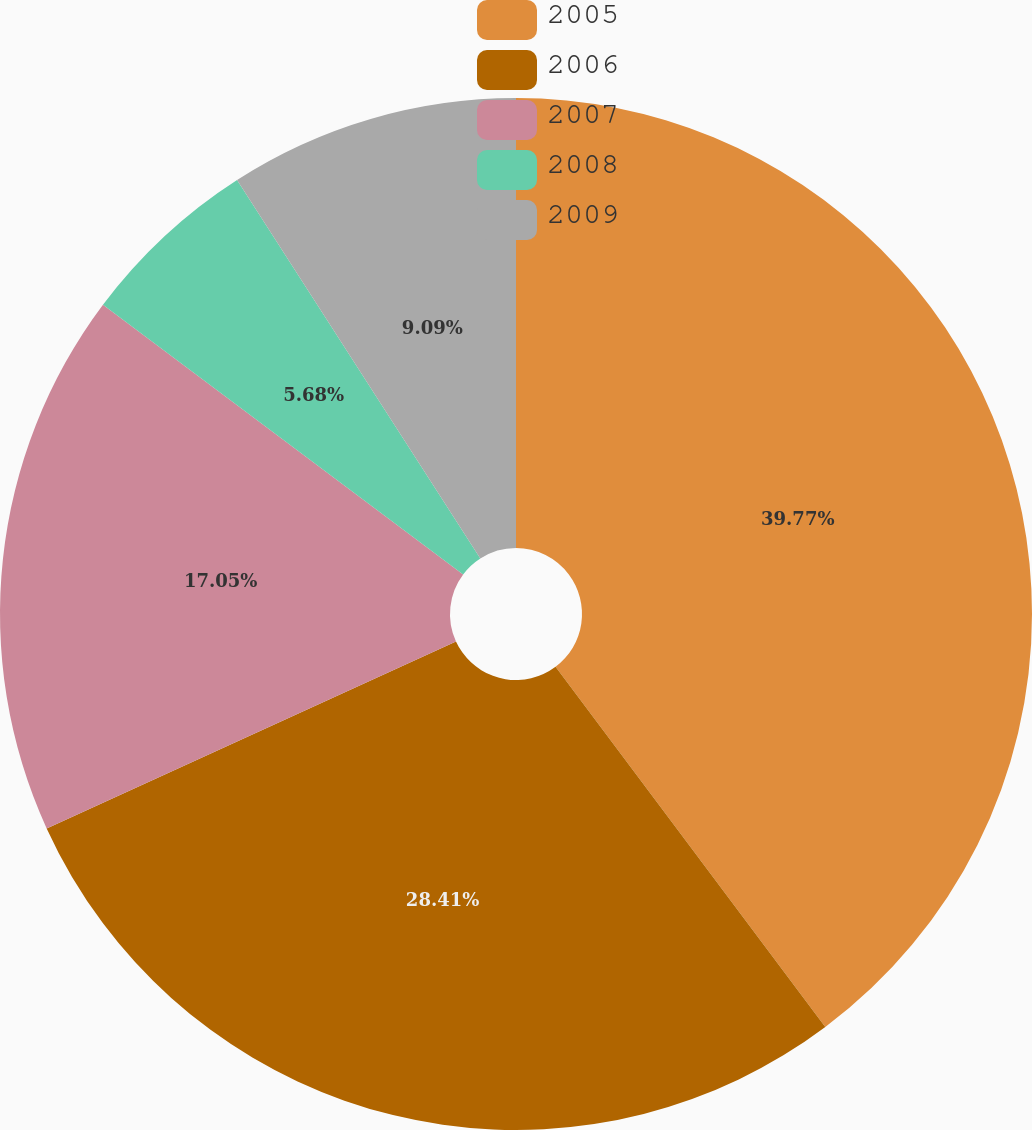<chart> <loc_0><loc_0><loc_500><loc_500><pie_chart><fcel>2005<fcel>2006<fcel>2007<fcel>2008<fcel>2009<nl><fcel>39.77%<fcel>28.41%<fcel>17.05%<fcel>5.68%<fcel>9.09%<nl></chart> 